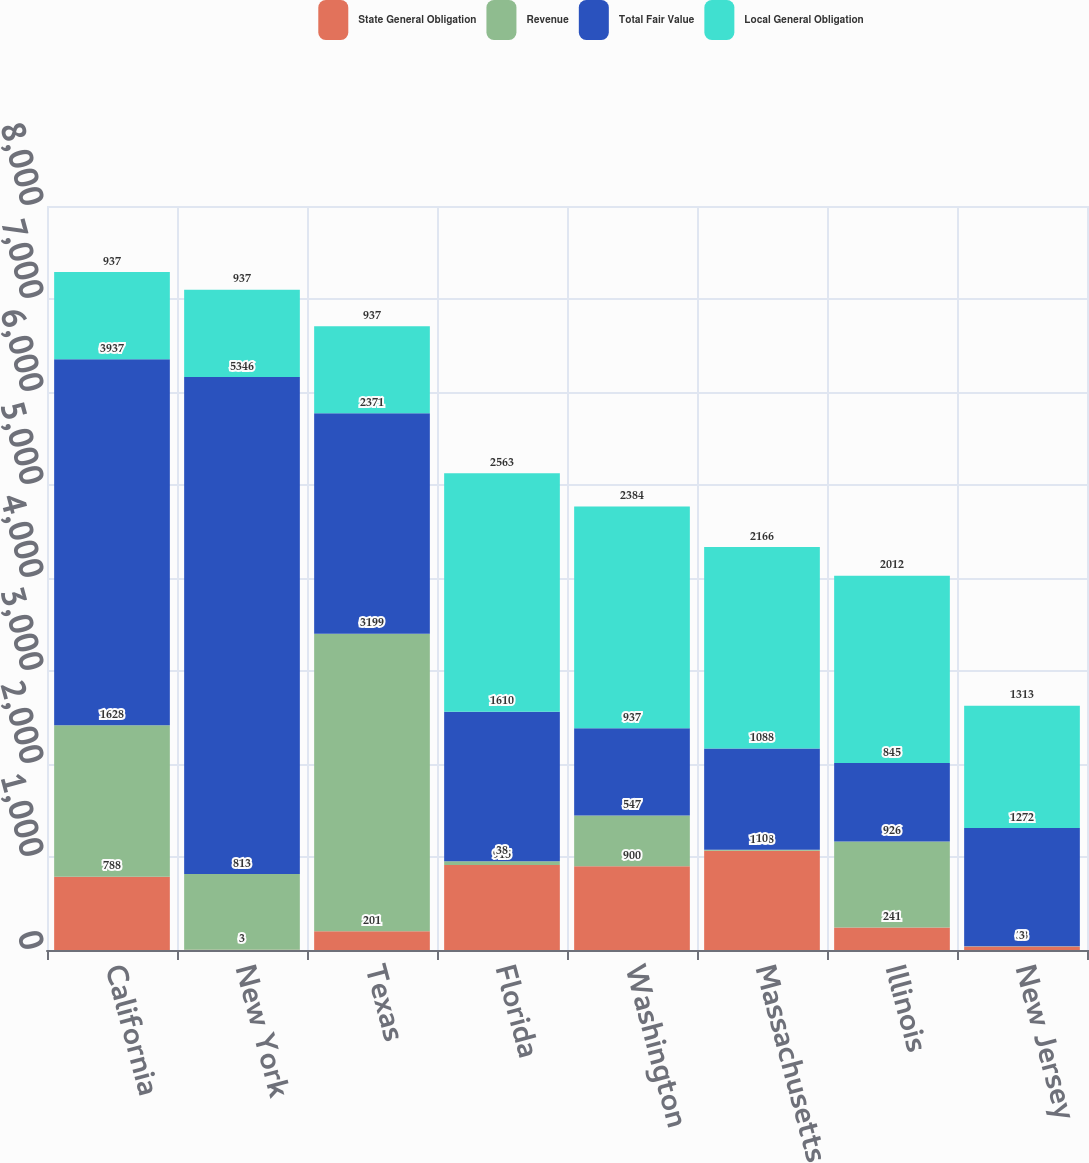Convert chart. <chart><loc_0><loc_0><loc_500><loc_500><stacked_bar_chart><ecel><fcel>California<fcel>New York<fcel>Texas<fcel>Florida<fcel>Washington<fcel>Massachusetts<fcel>Illinois<fcel>New Jersey<nl><fcel>State General Obligation<fcel>788<fcel>3<fcel>201<fcel>915<fcel>900<fcel>1068<fcel>241<fcel>38<nl><fcel>Revenue<fcel>1628<fcel>813<fcel>3199<fcel>38<fcel>547<fcel>10<fcel>926<fcel>3<nl><fcel>Total Fair Value<fcel>3937<fcel>5346<fcel>2371<fcel>1610<fcel>937<fcel>1088<fcel>845<fcel>1272<nl><fcel>Local General Obligation<fcel>937<fcel>937<fcel>937<fcel>2563<fcel>2384<fcel>2166<fcel>2012<fcel>1313<nl></chart> 